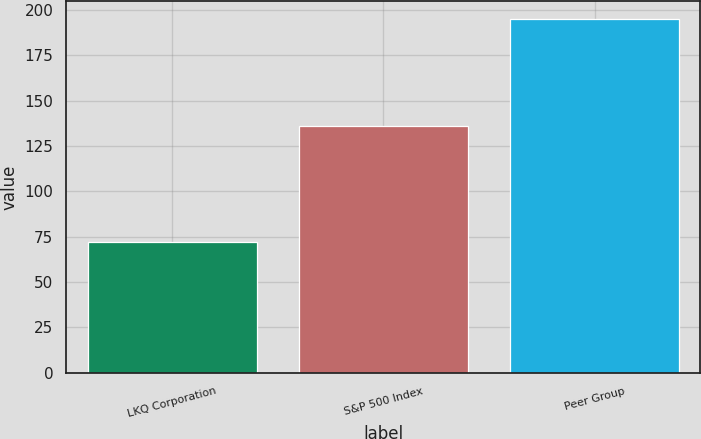Convert chart. <chart><loc_0><loc_0><loc_500><loc_500><bar_chart><fcel>LKQ Corporation<fcel>S&P 500 Index<fcel>Peer Group<nl><fcel>72<fcel>136<fcel>195<nl></chart> 